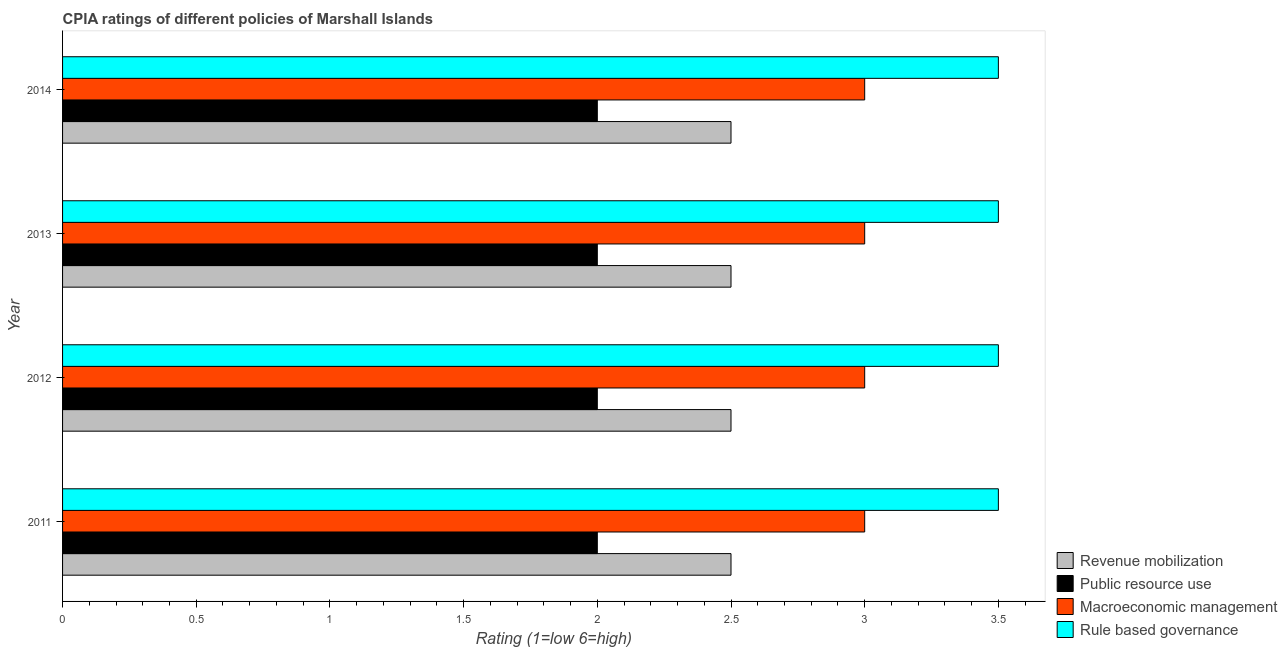How many different coloured bars are there?
Your response must be concise. 4. How many groups of bars are there?
Your answer should be very brief. 4. How many bars are there on the 3rd tick from the top?
Provide a short and direct response. 4. How many bars are there on the 2nd tick from the bottom?
Offer a very short reply. 4. What is the label of the 1st group of bars from the top?
Keep it short and to the point. 2014. In how many cases, is the number of bars for a given year not equal to the number of legend labels?
Offer a terse response. 0. Across all years, what is the minimum cpia rating of macroeconomic management?
Offer a terse response. 3. In which year was the cpia rating of revenue mobilization maximum?
Ensure brevity in your answer.  2011. What is the total cpia rating of public resource use in the graph?
Make the answer very short. 8. What is the difference between the cpia rating of macroeconomic management in 2013 and the cpia rating of public resource use in 2011?
Keep it short and to the point. 1. What is the average cpia rating of revenue mobilization per year?
Your response must be concise. 2.5. In the year 2011, what is the difference between the cpia rating of public resource use and cpia rating of macroeconomic management?
Provide a succinct answer. -1. What is the ratio of the cpia rating of public resource use in 2011 to that in 2012?
Your answer should be compact. 1. Is the cpia rating of public resource use in 2013 less than that in 2014?
Provide a short and direct response. No. Is the difference between the cpia rating of rule based governance in 2012 and 2013 greater than the difference between the cpia rating of public resource use in 2012 and 2013?
Your answer should be compact. No. What is the difference between the highest and the second highest cpia rating of revenue mobilization?
Your answer should be very brief. 0. Is it the case that in every year, the sum of the cpia rating of rule based governance and cpia rating of revenue mobilization is greater than the sum of cpia rating of public resource use and cpia rating of macroeconomic management?
Give a very brief answer. Yes. What does the 2nd bar from the top in 2014 represents?
Provide a succinct answer. Macroeconomic management. What does the 3rd bar from the bottom in 2011 represents?
Ensure brevity in your answer.  Macroeconomic management. How many years are there in the graph?
Provide a succinct answer. 4. What is the difference between two consecutive major ticks on the X-axis?
Your answer should be compact. 0.5. Does the graph contain grids?
Your answer should be compact. No. Where does the legend appear in the graph?
Keep it short and to the point. Bottom right. How are the legend labels stacked?
Offer a very short reply. Vertical. What is the title of the graph?
Provide a succinct answer. CPIA ratings of different policies of Marshall Islands. Does "Primary schools" appear as one of the legend labels in the graph?
Your answer should be very brief. No. What is the label or title of the Y-axis?
Provide a short and direct response. Year. What is the Rating (1=low 6=high) in Macroeconomic management in 2011?
Offer a terse response. 3. What is the Rating (1=low 6=high) of Revenue mobilization in 2012?
Give a very brief answer. 2.5. What is the Rating (1=low 6=high) in Rule based governance in 2012?
Offer a terse response. 3.5. What is the Rating (1=low 6=high) of Macroeconomic management in 2013?
Ensure brevity in your answer.  3. What is the Rating (1=low 6=high) of Rule based governance in 2013?
Ensure brevity in your answer.  3.5. What is the Rating (1=low 6=high) in Rule based governance in 2014?
Your answer should be very brief. 3.5. Across all years, what is the maximum Rating (1=low 6=high) of Revenue mobilization?
Keep it short and to the point. 2.5. Across all years, what is the maximum Rating (1=low 6=high) in Macroeconomic management?
Your response must be concise. 3. Across all years, what is the maximum Rating (1=low 6=high) in Rule based governance?
Your answer should be compact. 3.5. Across all years, what is the minimum Rating (1=low 6=high) of Revenue mobilization?
Offer a very short reply. 2.5. Across all years, what is the minimum Rating (1=low 6=high) of Rule based governance?
Offer a very short reply. 3.5. What is the total Rating (1=low 6=high) of Public resource use in the graph?
Give a very brief answer. 8. What is the difference between the Rating (1=low 6=high) of Macroeconomic management in 2011 and that in 2012?
Offer a terse response. 0. What is the difference between the Rating (1=low 6=high) of Rule based governance in 2011 and that in 2012?
Offer a very short reply. 0. What is the difference between the Rating (1=low 6=high) of Revenue mobilization in 2011 and that in 2013?
Keep it short and to the point. 0. What is the difference between the Rating (1=low 6=high) in Macroeconomic management in 2011 and that in 2013?
Your response must be concise. 0. What is the difference between the Rating (1=low 6=high) in Rule based governance in 2011 and that in 2013?
Keep it short and to the point. 0. What is the difference between the Rating (1=low 6=high) in Revenue mobilization in 2011 and that in 2014?
Ensure brevity in your answer.  0. What is the difference between the Rating (1=low 6=high) of Public resource use in 2011 and that in 2014?
Make the answer very short. 0. What is the difference between the Rating (1=low 6=high) in Revenue mobilization in 2012 and that in 2013?
Provide a succinct answer. 0. What is the difference between the Rating (1=low 6=high) in Public resource use in 2012 and that in 2013?
Make the answer very short. 0. What is the difference between the Rating (1=low 6=high) of Public resource use in 2012 and that in 2014?
Your answer should be very brief. 0. What is the difference between the Rating (1=low 6=high) of Rule based governance in 2012 and that in 2014?
Provide a succinct answer. 0. What is the difference between the Rating (1=low 6=high) of Revenue mobilization in 2013 and that in 2014?
Keep it short and to the point. 0. What is the difference between the Rating (1=low 6=high) in Public resource use in 2013 and that in 2014?
Keep it short and to the point. 0. What is the difference between the Rating (1=low 6=high) in Rule based governance in 2013 and that in 2014?
Provide a short and direct response. 0. What is the difference between the Rating (1=low 6=high) in Revenue mobilization in 2011 and the Rating (1=low 6=high) in Public resource use in 2012?
Offer a very short reply. 0.5. What is the difference between the Rating (1=low 6=high) of Revenue mobilization in 2011 and the Rating (1=low 6=high) of Macroeconomic management in 2012?
Make the answer very short. -0.5. What is the difference between the Rating (1=low 6=high) in Revenue mobilization in 2011 and the Rating (1=low 6=high) in Rule based governance in 2012?
Offer a terse response. -1. What is the difference between the Rating (1=low 6=high) of Public resource use in 2011 and the Rating (1=low 6=high) of Rule based governance in 2012?
Your answer should be compact. -1.5. What is the difference between the Rating (1=low 6=high) in Macroeconomic management in 2011 and the Rating (1=low 6=high) in Rule based governance in 2012?
Your answer should be very brief. -0.5. What is the difference between the Rating (1=low 6=high) of Public resource use in 2011 and the Rating (1=low 6=high) of Macroeconomic management in 2013?
Offer a terse response. -1. What is the difference between the Rating (1=low 6=high) in Public resource use in 2011 and the Rating (1=low 6=high) in Rule based governance in 2013?
Offer a terse response. -1.5. What is the difference between the Rating (1=low 6=high) in Macroeconomic management in 2011 and the Rating (1=low 6=high) in Rule based governance in 2013?
Your response must be concise. -0.5. What is the difference between the Rating (1=low 6=high) in Revenue mobilization in 2011 and the Rating (1=low 6=high) in Macroeconomic management in 2014?
Provide a short and direct response. -0.5. What is the difference between the Rating (1=low 6=high) in Revenue mobilization in 2011 and the Rating (1=low 6=high) in Rule based governance in 2014?
Ensure brevity in your answer.  -1. What is the difference between the Rating (1=low 6=high) in Public resource use in 2011 and the Rating (1=low 6=high) in Rule based governance in 2014?
Offer a terse response. -1.5. What is the difference between the Rating (1=low 6=high) in Macroeconomic management in 2011 and the Rating (1=low 6=high) in Rule based governance in 2014?
Offer a terse response. -0.5. What is the difference between the Rating (1=low 6=high) in Revenue mobilization in 2012 and the Rating (1=low 6=high) in Public resource use in 2013?
Provide a succinct answer. 0.5. What is the difference between the Rating (1=low 6=high) of Revenue mobilization in 2012 and the Rating (1=low 6=high) of Macroeconomic management in 2013?
Ensure brevity in your answer.  -0.5. What is the difference between the Rating (1=low 6=high) in Revenue mobilization in 2012 and the Rating (1=low 6=high) in Rule based governance in 2013?
Ensure brevity in your answer.  -1. What is the difference between the Rating (1=low 6=high) of Public resource use in 2012 and the Rating (1=low 6=high) of Macroeconomic management in 2013?
Your answer should be very brief. -1. What is the difference between the Rating (1=low 6=high) in Public resource use in 2012 and the Rating (1=low 6=high) in Rule based governance in 2013?
Ensure brevity in your answer.  -1.5. What is the difference between the Rating (1=low 6=high) in Revenue mobilization in 2012 and the Rating (1=low 6=high) in Public resource use in 2014?
Make the answer very short. 0.5. What is the difference between the Rating (1=low 6=high) of Macroeconomic management in 2012 and the Rating (1=low 6=high) of Rule based governance in 2014?
Provide a succinct answer. -0.5. What is the difference between the Rating (1=low 6=high) of Revenue mobilization in 2013 and the Rating (1=low 6=high) of Public resource use in 2014?
Your response must be concise. 0.5. What is the difference between the Rating (1=low 6=high) of Revenue mobilization in 2013 and the Rating (1=low 6=high) of Rule based governance in 2014?
Make the answer very short. -1. What is the difference between the Rating (1=low 6=high) of Public resource use in 2013 and the Rating (1=low 6=high) of Macroeconomic management in 2014?
Provide a succinct answer. -1. In the year 2011, what is the difference between the Rating (1=low 6=high) in Revenue mobilization and Rating (1=low 6=high) in Public resource use?
Keep it short and to the point. 0.5. In the year 2011, what is the difference between the Rating (1=low 6=high) in Revenue mobilization and Rating (1=low 6=high) in Macroeconomic management?
Provide a short and direct response. -0.5. In the year 2011, what is the difference between the Rating (1=low 6=high) of Public resource use and Rating (1=low 6=high) of Rule based governance?
Make the answer very short. -1.5. In the year 2011, what is the difference between the Rating (1=low 6=high) of Macroeconomic management and Rating (1=low 6=high) of Rule based governance?
Your answer should be very brief. -0.5. In the year 2012, what is the difference between the Rating (1=low 6=high) in Public resource use and Rating (1=low 6=high) in Macroeconomic management?
Provide a succinct answer. -1. In the year 2013, what is the difference between the Rating (1=low 6=high) of Public resource use and Rating (1=low 6=high) of Rule based governance?
Give a very brief answer. -1.5. In the year 2014, what is the difference between the Rating (1=low 6=high) of Revenue mobilization and Rating (1=low 6=high) of Macroeconomic management?
Provide a short and direct response. -0.5. In the year 2014, what is the difference between the Rating (1=low 6=high) of Revenue mobilization and Rating (1=low 6=high) of Rule based governance?
Keep it short and to the point. -1. In the year 2014, what is the difference between the Rating (1=low 6=high) in Macroeconomic management and Rating (1=low 6=high) in Rule based governance?
Provide a short and direct response. -0.5. What is the ratio of the Rating (1=low 6=high) in Macroeconomic management in 2011 to that in 2012?
Your answer should be very brief. 1. What is the ratio of the Rating (1=low 6=high) in Public resource use in 2011 to that in 2013?
Keep it short and to the point. 1. What is the ratio of the Rating (1=low 6=high) in Macroeconomic management in 2011 to that in 2013?
Keep it short and to the point. 1. What is the ratio of the Rating (1=low 6=high) of Macroeconomic management in 2011 to that in 2014?
Provide a short and direct response. 1. What is the ratio of the Rating (1=low 6=high) in Macroeconomic management in 2012 to that in 2013?
Keep it short and to the point. 1. What is the ratio of the Rating (1=low 6=high) of Public resource use in 2012 to that in 2014?
Keep it short and to the point. 1. What is the ratio of the Rating (1=low 6=high) of Macroeconomic management in 2012 to that in 2014?
Make the answer very short. 1. What is the ratio of the Rating (1=low 6=high) in Rule based governance in 2012 to that in 2014?
Provide a succinct answer. 1. What is the difference between the highest and the second highest Rating (1=low 6=high) in Public resource use?
Offer a terse response. 0. What is the difference between the highest and the second highest Rating (1=low 6=high) in Macroeconomic management?
Your answer should be very brief. 0. What is the difference between the highest and the lowest Rating (1=low 6=high) in Revenue mobilization?
Your answer should be very brief. 0. What is the difference between the highest and the lowest Rating (1=low 6=high) in Macroeconomic management?
Your answer should be compact. 0. What is the difference between the highest and the lowest Rating (1=low 6=high) in Rule based governance?
Provide a succinct answer. 0. 